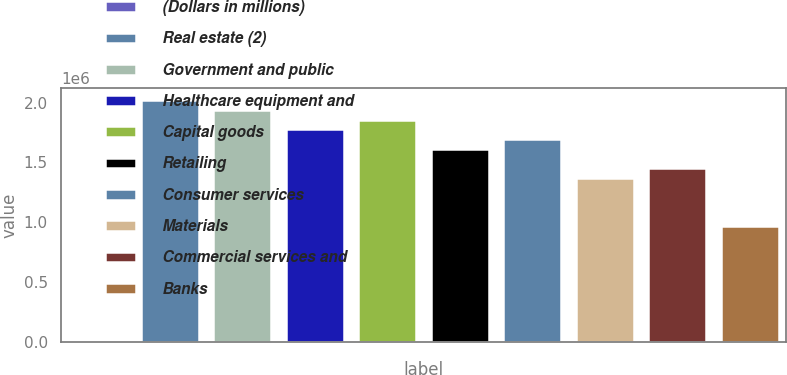<chart> <loc_0><loc_0><loc_500><loc_500><bar_chart><fcel>(Dollars in millions)<fcel>Real estate (2)<fcel>Government and public<fcel>Healthcare equipment and<fcel>Capital goods<fcel>Retailing<fcel>Consumer services<fcel>Materials<fcel>Commercial services and<fcel>Banks<nl><fcel>2009<fcel>2.01745e+06<fcel>1.93683e+06<fcel>1.7756e+06<fcel>1.85622e+06<fcel>1.61436e+06<fcel>1.69498e+06<fcel>1.37251e+06<fcel>1.45313e+06<fcel>969421<nl></chart> 